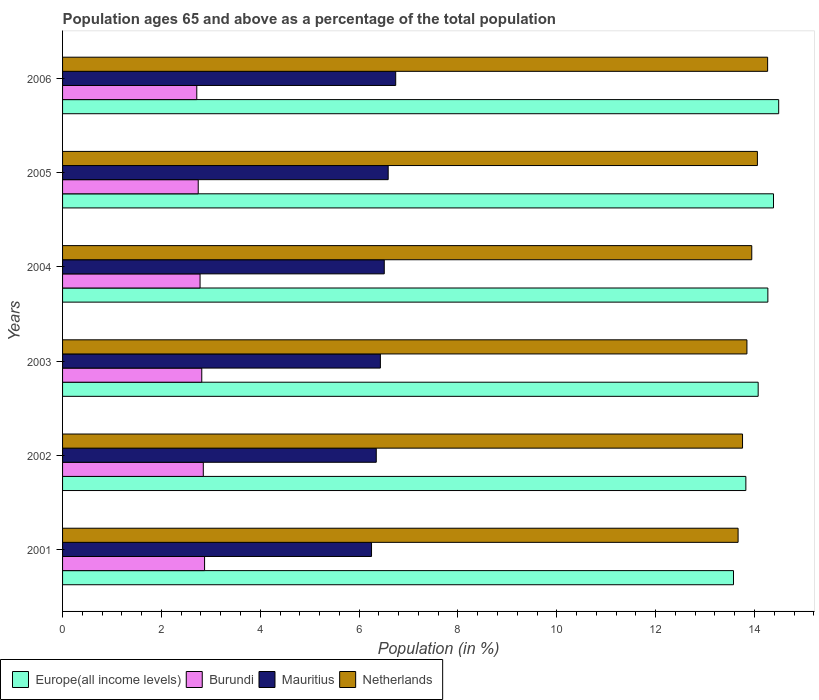Are the number of bars per tick equal to the number of legend labels?
Your answer should be very brief. Yes. Are the number of bars on each tick of the Y-axis equal?
Ensure brevity in your answer.  Yes. How many bars are there on the 4th tick from the top?
Give a very brief answer. 4. In how many cases, is the number of bars for a given year not equal to the number of legend labels?
Ensure brevity in your answer.  0. What is the percentage of the population ages 65 and above in Netherlands in 2001?
Provide a succinct answer. 13.67. Across all years, what is the maximum percentage of the population ages 65 and above in Mauritius?
Your response must be concise. 6.74. Across all years, what is the minimum percentage of the population ages 65 and above in Burundi?
Give a very brief answer. 2.72. In which year was the percentage of the population ages 65 and above in Netherlands maximum?
Give a very brief answer. 2006. What is the total percentage of the population ages 65 and above in Mauritius in the graph?
Make the answer very short. 38.87. What is the difference between the percentage of the population ages 65 and above in Europe(all income levels) in 2003 and that in 2005?
Give a very brief answer. -0.31. What is the difference between the percentage of the population ages 65 and above in Burundi in 2006 and the percentage of the population ages 65 and above in Europe(all income levels) in 2003?
Keep it short and to the point. -11.36. What is the average percentage of the population ages 65 and above in Mauritius per year?
Your response must be concise. 6.48. In the year 2003, what is the difference between the percentage of the population ages 65 and above in Netherlands and percentage of the population ages 65 and above in Mauritius?
Make the answer very short. 7.42. What is the ratio of the percentage of the population ages 65 and above in Burundi in 2002 to that in 2006?
Offer a terse response. 1.05. Is the percentage of the population ages 65 and above in Mauritius in 2002 less than that in 2003?
Offer a very short reply. Yes. Is the difference between the percentage of the population ages 65 and above in Netherlands in 2002 and 2003 greater than the difference between the percentage of the population ages 65 and above in Mauritius in 2002 and 2003?
Your answer should be compact. No. What is the difference between the highest and the second highest percentage of the population ages 65 and above in Netherlands?
Give a very brief answer. 0.21. What is the difference between the highest and the lowest percentage of the population ages 65 and above in Burundi?
Ensure brevity in your answer.  0.16. In how many years, is the percentage of the population ages 65 and above in Netherlands greater than the average percentage of the population ages 65 and above in Netherlands taken over all years?
Your response must be concise. 3. Is it the case that in every year, the sum of the percentage of the population ages 65 and above in Burundi and percentage of the population ages 65 and above in Europe(all income levels) is greater than the sum of percentage of the population ages 65 and above in Netherlands and percentage of the population ages 65 and above in Mauritius?
Offer a very short reply. Yes. What does the 4th bar from the top in 2001 represents?
Make the answer very short. Europe(all income levels). What does the 1st bar from the bottom in 2001 represents?
Your response must be concise. Europe(all income levels). How many years are there in the graph?
Make the answer very short. 6. What is the difference between two consecutive major ticks on the X-axis?
Provide a succinct answer. 2. Does the graph contain any zero values?
Provide a short and direct response. No. Does the graph contain grids?
Your answer should be very brief. No. What is the title of the graph?
Ensure brevity in your answer.  Population ages 65 and above as a percentage of the total population. What is the label or title of the X-axis?
Ensure brevity in your answer.  Population (in %). What is the Population (in %) in Europe(all income levels) in 2001?
Make the answer very short. 13.57. What is the Population (in %) of Burundi in 2001?
Make the answer very short. 2.87. What is the Population (in %) of Mauritius in 2001?
Your response must be concise. 6.25. What is the Population (in %) in Netherlands in 2001?
Your response must be concise. 13.67. What is the Population (in %) in Europe(all income levels) in 2002?
Your response must be concise. 13.83. What is the Population (in %) in Burundi in 2002?
Your answer should be very brief. 2.85. What is the Population (in %) in Mauritius in 2002?
Your answer should be compact. 6.35. What is the Population (in %) of Netherlands in 2002?
Offer a very short reply. 13.76. What is the Population (in %) of Europe(all income levels) in 2003?
Your response must be concise. 14.07. What is the Population (in %) of Burundi in 2003?
Offer a terse response. 2.82. What is the Population (in %) of Mauritius in 2003?
Provide a short and direct response. 6.43. What is the Population (in %) of Netherlands in 2003?
Offer a terse response. 13.85. What is the Population (in %) in Europe(all income levels) in 2004?
Provide a succinct answer. 14.27. What is the Population (in %) of Burundi in 2004?
Your response must be concise. 2.78. What is the Population (in %) in Mauritius in 2004?
Provide a succinct answer. 6.51. What is the Population (in %) in Netherlands in 2004?
Provide a succinct answer. 13.94. What is the Population (in %) in Europe(all income levels) in 2005?
Ensure brevity in your answer.  14.38. What is the Population (in %) in Burundi in 2005?
Offer a terse response. 2.74. What is the Population (in %) in Mauritius in 2005?
Your response must be concise. 6.59. What is the Population (in %) in Netherlands in 2005?
Give a very brief answer. 14.06. What is the Population (in %) of Europe(all income levels) in 2006?
Provide a succinct answer. 14.49. What is the Population (in %) of Burundi in 2006?
Keep it short and to the point. 2.72. What is the Population (in %) of Mauritius in 2006?
Make the answer very short. 6.74. What is the Population (in %) in Netherlands in 2006?
Offer a terse response. 14.27. Across all years, what is the maximum Population (in %) of Europe(all income levels)?
Your response must be concise. 14.49. Across all years, what is the maximum Population (in %) in Burundi?
Your answer should be very brief. 2.87. Across all years, what is the maximum Population (in %) in Mauritius?
Offer a terse response. 6.74. Across all years, what is the maximum Population (in %) in Netherlands?
Ensure brevity in your answer.  14.27. Across all years, what is the minimum Population (in %) of Europe(all income levels)?
Keep it short and to the point. 13.57. Across all years, what is the minimum Population (in %) of Burundi?
Make the answer very short. 2.72. Across all years, what is the minimum Population (in %) of Mauritius?
Give a very brief answer. 6.25. Across all years, what is the minimum Population (in %) of Netherlands?
Offer a very short reply. 13.67. What is the total Population (in %) in Europe(all income levels) in the graph?
Your answer should be very brief. 84.62. What is the total Population (in %) in Burundi in the graph?
Your response must be concise. 16.78. What is the total Population (in %) in Mauritius in the graph?
Make the answer very short. 38.87. What is the total Population (in %) in Netherlands in the graph?
Your response must be concise. 83.54. What is the difference between the Population (in %) in Europe(all income levels) in 2001 and that in 2002?
Offer a terse response. -0.25. What is the difference between the Population (in %) in Burundi in 2001 and that in 2002?
Make the answer very short. 0.03. What is the difference between the Population (in %) in Mauritius in 2001 and that in 2002?
Offer a terse response. -0.1. What is the difference between the Population (in %) of Netherlands in 2001 and that in 2002?
Keep it short and to the point. -0.09. What is the difference between the Population (in %) in Europe(all income levels) in 2001 and that in 2003?
Make the answer very short. -0.5. What is the difference between the Population (in %) in Burundi in 2001 and that in 2003?
Your response must be concise. 0.06. What is the difference between the Population (in %) in Mauritius in 2001 and that in 2003?
Offer a very short reply. -0.18. What is the difference between the Population (in %) of Netherlands in 2001 and that in 2003?
Your answer should be compact. -0.18. What is the difference between the Population (in %) in Europe(all income levels) in 2001 and that in 2004?
Your response must be concise. -0.7. What is the difference between the Population (in %) of Burundi in 2001 and that in 2004?
Offer a terse response. 0.09. What is the difference between the Population (in %) of Mauritius in 2001 and that in 2004?
Give a very brief answer. -0.26. What is the difference between the Population (in %) of Netherlands in 2001 and that in 2004?
Your response must be concise. -0.28. What is the difference between the Population (in %) in Europe(all income levels) in 2001 and that in 2005?
Your response must be concise. -0.81. What is the difference between the Population (in %) of Burundi in 2001 and that in 2005?
Provide a succinct answer. 0.13. What is the difference between the Population (in %) of Mauritius in 2001 and that in 2005?
Your answer should be very brief. -0.34. What is the difference between the Population (in %) of Netherlands in 2001 and that in 2005?
Provide a succinct answer. -0.39. What is the difference between the Population (in %) of Europe(all income levels) in 2001 and that in 2006?
Give a very brief answer. -0.91. What is the difference between the Population (in %) in Burundi in 2001 and that in 2006?
Your answer should be very brief. 0.16. What is the difference between the Population (in %) of Mauritius in 2001 and that in 2006?
Your answer should be compact. -0.49. What is the difference between the Population (in %) in Netherlands in 2001 and that in 2006?
Your answer should be very brief. -0.6. What is the difference between the Population (in %) of Europe(all income levels) in 2002 and that in 2003?
Your answer should be very brief. -0.25. What is the difference between the Population (in %) of Burundi in 2002 and that in 2003?
Give a very brief answer. 0.03. What is the difference between the Population (in %) in Mauritius in 2002 and that in 2003?
Your response must be concise. -0.08. What is the difference between the Population (in %) of Netherlands in 2002 and that in 2003?
Your answer should be very brief. -0.09. What is the difference between the Population (in %) in Europe(all income levels) in 2002 and that in 2004?
Your answer should be compact. -0.45. What is the difference between the Population (in %) in Burundi in 2002 and that in 2004?
Your answer should be very brief. 0.07. What is the difference between the Population (in %) in Mauritius in 2002 and that in 2004?
Make the answer very short. -0.16. What is the difference between the Population (in %) of Netherlands in 2002 and that in 2004?
Keep it short and to the point. -0.19. What is the difference between the Population (in %) of Europe(all income levels) in 2002 and that in 2005?
Provide a short and direct response. -0.56. What is the difference between the Population (in %) of Burundi in 2002 and that in 2005?
Provide a succinct answer. 0.1. What is the difference between the Population (in %) of Mauritius in 2002 and that in 2005?
Your answer should be very brief. -0.24. What is the difference between the Population (in %) of Netherlands in 2002 and that in 2005?
Offer a very short reply. -0.3. What is the difference between the Population (in %) in Europe(all income levels) in 2002 and that in 2006?
Keep it short and to the point. -0.66. What is the difference between the Population (in %) in Burundi in 2002 and that in 2006?
Ensure brevity in your answer.  0.13. What is the difference between the Population (in %) in Mauritius in 2002 and that in 2006?
Give a very brief answer. -0.39. What is the difference between the Population (in %) of Netherlands in 2002 and that in 2006?
Make the answer very short. -0.51. What is the difference between the Population (in %) in Europe(all income levels) in 2003 and that in 2004?
Give a very brief answer. -0.2. What is the difference between the Population (in %) of Burundi in 2003 and that in 2004?
Offer a terse response. 0.03. What is the difference between the Population (in %) in Mauritius in 2003 and that in 2004?
Make the answer very short. -0.08. What is the difference between the Population (in %) in Netherlands in 2003 and that in 2004?
Your answer should be very brief. -0.1. What is the difference between the Population (in %) of Europe(all income levels) in 2003 and that in 2005?
Offer a very short reply. -0.31. What is the difference between the Population (in %) in Burundi in 2003 and that in 2005?
Your answer should be very brief. 0.07. What is the difference between the Population (in %) in Mauritius in 2003 and that in 2005?
Give a very brief answer. -0.16. What is the difference between the Population (in %) of Netherlands in 2003 and that in 2005?
Make the answer very short. -0.21. What is the difference between the Population (in %) of Europe(all income levels) in 2003 and that in 2006?
Provide a succinct answer. -0.41. What is the difference between the Population (in %) in Burundi in 2003 and that in 2006?
Provide a short and direct response. 0.1. What is the difference between the Population (in %) in Mauritius in 2003 and that in 2006?
Give a very brief answer. -0.31. What is the difference between the Population (in %) of Netherlands in 2003 and that in 2006?
Your answer should be very brief. -0.42. What is the difference between the Population (in %) in Europe(all income levels) in 2004 and that in 2005?
Keep it short and to the point. -0.11. What is the difference between the Population (in %) in Burundi in 2004 and that in 2005?
Keep it short and to the point. 0.04. What is the difference between the Population (in %) in Mauritius in 2004 and that in 2005?
Offer a very short reply. -0.08. What is the difference between the Population (in %) in Netherlands in 2004 and that in 2005?
Provide a succinct answer. -0.11. What is the difference between the Population (in %) in Europe(all income levels) in 2004 and that in 2006?
Offer a very short reply. -0.22. What is the difference between the Population (in %) in Burundi in 2004 and that in 2006?
Offer a terse response. 0.07. What is the difference between the Population (in %) of Mauritius in 2004 and that in 2006?
Your response must be concise. -0.23. What is the difference between the Population (in %) of Netherlands in 2004 and that in 2006?
Keep it short and to the point. -0.32. What is the difference between the Population (in %) in Europe(all income levels) in 2005 and that in 2006?
Provide a short and direct response. -0.1. What is the difference between the Population (in %) of Burundi in 2005 and that in 2006?
Offer a terse response. 0.03. What is the difference between the Population (in %) of Mauritius in 2005 and that in 2006?
Give a very brief answer. -0.15. What is the difference between the Population (in %) of Netherlands in 2005 and that in 2006?
Your response must be concise. -0.21. What is the difference between the Population (in %) of Europe(all income levels) in 2001 and the Population (in %) of Burundi in 2002?
Your answer should be very brief. 10.73. What is the difference between the Population (in %) of Europe(all income levels) in 2001 and the Population (in %) of Mauritius in 2002?
Your answer should be very brief. 7.23. What is the difference between the Population (in %) of Europe(all income levels) in 2001 and the Population (in %) of Netherlands in 2002?
Keep it short and to the point. -0.18. What is the difference between the Population (in %) of Burundi in 2001 and the Population (in %) of Mauritius in 2002?
Offer a very short reply. -3.47. What is the difference between the Population (in %) of Burundi in 2001 and the Population (in %) of Netherlands in 2002?
Provide a succinct answer. -10.88. What is the difference between the Population (in %) of Mauritius in 2001 and the Population (in %) of Netherlands in 2002?
Ensure brevity in your answer.  -7.51. What is the difference between the Population (in %) in Europe(all income levels) in 2001 and the Population (in %) in Burundi in 2003?
Your response must be concise. 10.76. What is the difference between the Population (in %) in Europe(all income levels) in 2001 and the Population (in %) in Mauritius in 2003?
Provide a succinct answer. 7.14. What is the difference between the Population (in %) in Europe(all income levels) in 2001 and the Population (in %) in Netherlands in 2003?
Make the answer very short. -0.27. What is the difference between the Population (in %) in Burundi in 2001 and the Population (in %) in Mauritius in 2003?
Provide a succinct answer. -3.56. What is the difference between the Population (in %) of Burundi in 2001 and the Population (in %) of Netherlands in 2003?
Your answer should be very brief. -10.97. What is the difference between the Population (in %) in Mauritius in 2001 and the Population (in %) in Netherlands in 2003?
Provide a short and direct response. -7.6. What is the difference between the Population (in %) in Europe(all income levels) in 2001 and the Population (in %) in Burundi in 2004?
Give a very brief answer. 10.79. What is the difference between the Population (in %) of Europe(all income levels) in 2001 and the Population (in %) of Mauritius in 2004?
Offer a very short reply. 7.07. What is the difference between the Population (in %) of Europe(all income levels) in 2001 and the Population (in %) of Netherlands in 2004?
Your response must be concise. -0.37. What is the difference between the Population (in %) in Burundi in 2001 and the Population (in %) in Mauritius in 2004?
Provide a short and direct response. -3.64. What is the difference between the Population (in %) in Burundi in 2001 and the Population (in %) in Netherlands in 2004?
Provide a succinct answer. -11.07. What is the difference between the Population (in %) of Mauritius in 2001 and the Population (in %) of Netherlands in 2004?
Keep it short and to the point. -7.69. What is the difference between the Population (in %) of Europe(all income levels) in 2001 and the Population (in %) of Burundi in 2005?
Ensure brevity in your answer.  10.83. What is the difference between the Population (in %) in Europe(all income levels) in 2001 and the Population (in %) in Mauritius in 2005?
Your response must be concise. 6.99. What is the difference between the Population (in %) of Europe(all income levels) in 2001 and the Population (in %) of Netherlands in 2005?
Offer a very short reply. -0.48. What is the difference between the Population (in %) in Burundi in 2001 and the Population (in %) in Mauritius in 2005?
Keep it short and to the point. -3.71. What is the difference between the Population (in %) of Burundi in 2001 and the Population (in %) of Netherlands in 2005?
Your response must be concise. -11.19. What is the difference between the Population (in %) of Mauritius in 2001 and the Population (in %) of Netherlands in 2005?
Your answer should be very brief. -7.81. What is the difference between the Population (in %) of Europe(all income levels) in 2001 and the Population (in %) of Burundi in 2006?
Make the answer very short. 10.86. What is the difference between the Population (in %) in Europe(all income levels) in 2001 and the Population (in %) in Mauritius in 2006?
Make the answer very short. 6.83. What is the difference between the Population (in %) of Europe(all income levels) in 2001 and the Population (in %) of Netherlands in 2006?
Your answer should be compact. -0.69. What is the difference between the Population (in %) of Burundi in 2001 and the Population (in %) of Mauritius in 2006?
Your response must be concise. -3.87. What is the difference between the Population (in %) of Burundi in 2001 and the Population (in %) of Netherlands in 2006?
Keep it short and to the point. -11.39. What is the difference between the Population (in %) of Mauritius in 2001 and the Population (in %) of Netherlands in 2006?
Your response must be concise. -8.01. What is the difference between the Population (in %) in Europe(all income levels) in 2002 and the Population (in %) in Burundi in 2003?
Your answer should be compact. 11.01. What is the difference between the Population (in %) of Europe(all income levels) in 2002 and the Population (in %) of Mauritius in 2003?
Make the answer very short. 7.39. What is the difference between the Population (in %) in Europe(all income levels) in 2002 and the Population (in %) in Netherlands in 2003?
Give a very brief answer. -0.02. What is the difference between the Population (in %) of Burundi in 2002 and the Population (in %) of Mauritius in 2003?
Keep it short and to the point. -3.58. What is the difference between the Population (in %) of Burundi in 2002 and the Population (in %) of Netherlands in 2003?
Offer a very short reply. -11. What is the difference between the Population (in %) of Mauritius in 2002 and the Population (in %) of Netherlands in 2003?
Offer a very short reply. -7.5. What is the difference between the Population (in %) of Europe(all income levels) in 2002 and the Population (in %) of Burundi in 2004?
Your response must be concise. 11.04. What is the difference between the Population (in %) in Europe(all income levels) in 2002 and the Population (in %) in Mauritius in 2004?
Provide a succinct answer. 7.32. What is the difference between the Population (in %) in Europe(all income levels) in 2002 and the Population (in %) in Netherlands in 2004?
Ensure brevity in your answer.  -0.12. What is the difference between the Population (in %) in Burundi in 2002 and the Population (in %) in Mauritius in 2004?
Provide a short and direct response. -3.66. What is the difference between the Population (in %) of Burundi in 2002 and the Population (in %) of Netherlands in 2004?
Offer a very short reply. -11.1. What is the difference between the Population (in %) of Mauritius in 2002 and the Population (in %) of Netherlands in 2004?
Make the answer very short. -7.6. What is the difference between the Population (in %) in Europe(all income levels) in 2002 and the Population (in %) in Burundi in 2005?
Keep it short and to the point. 11.08. What is the difference between the Population (in %) of Europe(all income levels) in 2002 and the Population (in %) of Mauritius in 2005?
Offer a terse response. 7.24. What is the difference between the Population (in %) in Europe(all income levels) in 2002 and the Population (in %) in Netherlands in 2005?
Provide a succinct answer. -0.23. What is the difference between the Population (in %) of Burundi in 2002 and the Population (in %) of Mauritius in 2005?
Provide a succinct answer. -3.74. What is the difference between the Population (in %) of Burundi in 2002 and the Population (in %) of Netherlands in 2005?
Your answer should be compact. -11.21. What is the difference between the Population (in %) in Mauritius in 2002 and the Population (in %) in Netherlands in 2005?
Provide a succinct answer. -7.71. What is the difference between the Population (in %) of Europe(all income levels) in 2002 and the Population (in %) of Burundi in 2006?
Ensure brevity in your answer.  11.11. What is the difference between the Population (in %) of Europe(all income levels) in 2002 and the Population (in %) of Mauritius in 2006?
Provide a short and direct response. 7.08. What is the difference between the Population (in %) of Europe(all income levels) in 2002 and the Population (in %) of Netherlands in 2006?
Your response must be concise. -0.44. What is the difference between the Population (in %) of Burundi in 2002 and the Population (in %) of Mauritius in 2006?
Keep it short and to the point. -3.89. What is the difference between the Population (in %) of Burundi in 2002 and the Population (in %) of Netherlands in 2006?
Your answer should be compact. -11.42. What is the difference between the Population (in %) in Mauritius in 2002 and the Population (in %) in Netherlands in 2006?
Ensure brevity in your answer.  -7.92. What is the difference between the Population (in %) of Europe(all income levels) in 2003 and the Population (in %) of Burundi in 2004?
Keep it short and to the point. 11.29. What is the difference between the Population (in %) in Europe(all income levels) in 2003 and the Population (in %) in Mauritius in 2004?
Provide a short and direct response. 7.57. What is the difference between the Population (in %) in Europe(all income levels) in 2003 and the Population (in %) in Netherlands in 2004?
Make the answer very short. 0.13. What is the difference between the Population (in %) in Burundi in 2003 and the Population (in %) in Mauritius in 2004?
Provide a short and direct response. -3.69. What is the difference between the Population (in %) of Burundi in 2003 and the Population (in %) of Netherlands in 2004?
Provide a succinct answer. -11.13. What is the difference between the Population (in %) in Mauritius in 2003 and the Population (in %) in Netherlands in 2004?
Offer a terse response. -7.51. What is the difference between the Population (in %) of Europe(all income levels) in 2003 and the Population (in %) of Burundi in 2005?
Offer a very short reply. 11.33. What is the difference between the Population (in %) of Europe(all income levels) in 2003 and the Population (in %) of Mauritius in 2005?
Your answer should be very brief. 7.49. What is the difference between the Population (in %) of Europe(all income levels) in 2003 and the Population (in %) of Netherlands in 2005?
Keep it short and to the point. 0.02. What is the difference between the Population (in %) in Burundi in 2003 and the Population (in %) in Mauritius in 2005?
Provide a succinct answer. -3.77. What is the difference between the Population (in %) of Burundi in 2003 and the Population (in %) of Netherlands in 2005?
Your response must be concise. -11.24. What is the difference between the Population (in %) of Mauritius in 2003 and the Population (in %) of Netherlands in 2005?
Make the answer very short. -7.63. What is the difference between the Population (in %) in Europe(all income levels) in 2003 and the Population (in %) in Burundi in 2006?
Give a very brief answer. 11.36. What is the difference between the Population (in %) of Europe(all income levels) in 2003 and the Population (in %) of Mauritius in 2006?
Ensure brevity in your answer.  7.33. What is the difference between the Population (in %) in Europe(all income levels) in 2003 and the Population (in %) in Netherlands in 2006?
Offer a very short reply. -0.19. What is the difference between the Population (in %) in Burundi in 2003 and the Population (in %) in Mauritius in 2006?
Offer a very short reply. -3.92. What is the difference between the Population (in %) of Burundi in 2003 and the Population (in %) of Netherlands in 2006?
Ensure brevity in your answer.  -11.45. What is the difference between the Population (in %) in Mauritius in 2003 and the Population (in %) in Netherlands in 2006?
Provide a short and direct response. -7.83. What is the difference between the Population (in %) of Europe(all income levels) in 2004 and the Population (in %) of Burundi in 2005?
Make the answer very short. 11.53. What is the difference between the Population (in %) of Europe(all income levels) in 2004 and the Population (in %) of Mauritius in 2005?
Give a very brief answer. 7.68. What is the difference between the Population (in %) in Europe(all income levels) in 2004 and the Population (in %) in Netherlands in 2005?
Ensure brevity in your answer.  0.21. What is the difference between the Population (in %) in Burundi in 2004 and the Population (in %) in Mauritius in 2005?
Your response must be concise. -3.81. What is the difference between the Population (in %) in Burundi in 2004 and the Population (in %) in Netherlands in 2005?
Make the answer very short. -11.28. What is the difference between the Population (in %) in Mauritius in 2004 and the Population (in %) in Netherlands in 2005?
Provide a succinct answer. -7.55. What is the difference between the Population (in %) in Europe(all income levels) in 2004 and the Population (in %) in Burundi in 2006?
Provide a succinct answer. 11.55. What is the difference between the Population (in %) of Europe(all income levels) in 2004 and the Population (in %) of Mauritius in 2006?
Offer a terse response. 7.53. What is the difference between the Population (in %) in Europe(all income levels) in 2004 and the Population (in %) in Netherlands in 2006?
Offer a very short reply. 0. What is the difference between the Population (in %) of Burundi in 2004 and the Population (in %) of Mauritius in 2006?
Offer a very short reply. -3.96. What is the difference between the Population (in %) of Burundi in 2004 and the Population (in %) of Netherlands in 2006?
Give a very brief answer. -11.48. What is the difference between the Population (in %) in Mauritius in 2004 and the Population (in %) in Netherlands in 2006?
Keep it short and to the point. -7.76. What is the difference between the Population (in %) of Europe(all income levels) in 2005 and the Population (in %) of Burundi in 2006?
Offer a very short reply. 11.67. What is the difference between the Population (in %) in Europe(all income levels) in 2005 and the Population (in %) in Mauritius in 2006?
Offer a very short reply. 7.64. What is the difference between the Population (in %) of Europe(all income levels) in 2005 and the Population (in %) of Netherlands in 2006?
Provide a short and direct response. 0.12. What is the difference between the Population (in %) of Burundi in 2005 and the Population (in %) of Mauritius in 2006?
Give a very brief answer. -4. What is the difference between the Population (in %) in Burundi in 2005 and the Population (in %) in Netherlands in 2006?
Your answer should be very brief. -11.52. What is the difference between the Population (in %) in Mauritius in 2005 and the Population (in %) in Netherlands in 2006?
Your response must be concise. -7.68. What is the average Population (in %) in Europe(all income levels) per year?
Your answer should be very brief. 14.1. What is the average Population (in %) in Burundi per year?
Your answer should be very brief. 2.8. What is the average Population (in %) of Mauritius per year?
Offer a very short reply. 6.48. What is the average Population (in %) of Netherlands per year?
Offer a terse response. 13.92. In the year 2001, what is the difference between the Population (in %) in Europe(all income levels) and Population (in %) in Burundi?
Offer a very short reply. 10.7. In the year 2001, what is the difference between the Population (in %) of Europe(all income levels) and Population (in %) of Mauritius?
Your answer should be very brief. 7.32. In the year 2001, what is the difference between the Population (in %) in Europe(all income levels) and Population (in %) in Netherlands?
Provide a succinct answer. -0.09. In the year 2001, what is the difference between the Population (in %) in Burundi and Population (in %) in Mauritius?
Keep it short and to the point. -3.38. In the year 2001, what is the difference between the Population (in %) in Burundi and Population (in %) in Netherlands?
Ensure brevity in your answer.  -10.79. In the year 2001, what is the difference between the Population (in %) in Mauritius and Population (in %) in Netherlands?
Keep it short and to the point. -7.42. In the year 2002, what is the difference between the Population (in %) in Europe(all income levels) and Population (in %) in Burundi?
Offer a very short reply. 10.98. In the year 2002, what is the difference between the Population (in %) of Europe(all income levels) and Population (in %) of Mauritius?
Provide a short and direct response. 7.48. In the year 2002, what is the difference between the Population (in %) of Europe(all income levels) and Population (in %) of Netherlands?
Keep it short and to the point. 0.07. In the year 2002, what is the difference between the Population (in %) in Burundi and Population (in %) in Mauritius?
Provide a succinct answer. -3.5. In the year 2002, what is the difference between the Population (in %) of Burundi and Population (in %) of Netherlands?
Your response must be concise. -10.91. In the year 2002, what is the difference between the Population (in %) in Mauritius and Population (in %) in Netherlands?
Ensure brevity in your answer.  -7.41. In the year 2003, what is the difference between the Population (in %) of Europe(all income levels) and Population (in %) of Burundi?
Give a very brief answer. 11.26. In the year 2003, what is the difference between the Population (in %) in Europe(all income levels) and Population (in %) in Mauritius?
Offer a very short reply. 7.64. In the year 2003, what is the difference between the Population (in %) in Europe(all income levels) and Population (in %) in Netherlands?
Your answer should be very brief. 0.23. In the year 2003, what is the difference between the Population (in %) in Burundi and Population (in %) in Mauritius?
Provide a short and direct response. -3.61. In the year 2003, what is the difference between the Population (in %) in Burundi and Population (in %) in Netherlands?
Provide a short and direct response. -11.03. In the year 2003, what is the difference between the Population (in %) in Mauritius and Population (in %) in Netherlands?
Provide a succinct answer. -7.42. In the year 2004, what is the difference between the Population (in %) in Europe(all income levels) and Population (in %) in Burundi?
Give a very brief answer. 11.49. In the year 2004, what is the difference between the Population (in %) of Europe(all income levels) and Population (in %) of Mauritius?
Ensure brevity in your answer.  7.76. In the year 2004, what is the difference between the Population (in %) of Europe(all income levels) and Population (in %) of Netherlands?
Provide a short and direct response. 0.33. In the year 2004, what is the difference between the Population (in %) of Burundi and Population (in %) of Mauritius?
Make the answer very short. -3.73. In the year 2004, what is the difference between the Population (in %) in Burundi and Population (in %) in Netherlands?
Provide a succinct answer. -11.16. In the year 2004, what is the difference between the Population (in %) of Mauritius and Population (in %) of Netherlands?
Make the answer very short. -7.44. In the year 2005, what is the difference between the Population (in %) of Europe(all income levels) and Population (in %) of Burundi?
Your answer should be compact. 11.64. In the year 2005, what is the difference between the Population (in %) of Europe(all income levels) and Population (in %) of Mauritius?
Offer a terse response. 7.8. In the year 2005, what is the difference between the Population (in %) of Europe(all income levels) and Population (in %) of Netherlands?
Your answer should be compact. 0.33. In the year 2005, what is the difference between the Population (in %) in Burundi and Population (in %) in Mauritius?
Your response must be concise. -3.84. In the year 2005, what is the difference between the Population (in %) in Burundi and Population (in %) in Netherlands?
Ensure brevity in your answer.  -11.31. In the year 2005, what is the difference between the Population (in %) of Mauritius and Population (in %) of Netherlands?
Give a very brief answer. -7.47. In the year 2006, what is the difference between the Population (in %) in Europe(all income levels) and Population (in %) in Burundi?
Provide a succinct answer. 11.77. In the year 2006, what is the difference between the Population (in %) in Europe(all income levels) and Population (in %) in Mauritius?
Your response must be concise. 7.75. In the year 2006, what is the difference between the Population (in %) of Europe(all income levels) and Population (in %) of Netherlands?
Make the answer very short. 0.22. In the year 2006, what is the difference between the Population (in %) in Burundi and Population (in %) in Mauritius?
Make the answer very short. -4.02. In the year 2006, what is the difference between the Population (in %) of Burundi and Population (in %) of Netherlands?
Your answer should be very brief. -11.55. In the year 2006, what is the difference between the Population (in %) of Mauritius and Population (in %) of Netherlands?
Give a very brief answer. -7.53. What is the ratio of the Population (in %) in Europe(all income levels) in 2001 to that in 2002?
Provide a short and direct response. 0.98. What is the ratio of the Population (in %) in Burundi in 2001 to that in 2002?
Ensure brevity in your answer.  1.01. What is the ratio of the Population (in %) in Mauritius in 2001 to that in 2002?
Offer a terse response. 0.98. What is the ratio of the Population (in %) of Netherlands in 2001 to that in 2002?
Provide a short and direct response. 0.99. What is the ratio of the Population (in %) in Europe(all income levels) in 2001 to that in 2003?
Provide a short and direct response. 0.96. What is the ratio of the Population (in %) of Burundi in 2001 to that in 2003?
Offer a very short reply. 1.02. What is the ratio of the Population (in %) in Mauritius in 2001 to that in 2003?
Keep it short and to the point. 0.97. What is the ratio of the Population (in %) of Netherlands in 2001 to that in 2003?
Your response must be concise. 0.99. What is the ratio of the Population (in %) of Europe(all income levels) in 2001 to that in 2004?
Your answer should be very brief. 0.95. What is the ratio of the Population (in %) of Burundi in 2001 to that in 2004?
Give a very brief answer. 1.03. What is the ratio of the Population (in %) in Mauritius in 2001 to that in 2004?
Provide a succinct answer. 0.96. What is the ratio of the Population (in %) in Netherlands in 2001 to that in 2004?
Your answer should be very brief. 0.98. What is the ratio of the Population (in %) in Europe(all income levels) in 2001 to that in 2005?
Keep it short and to the point. 0.94. What is the ratio of the Population (in %) of Burundi in 2001 to that in 2005?
Provide a short and direct response. 1.05. What is the ratio of the Population (in %) in Mauritius in 2001 to that in 2005?
Your answer should be very brief. 0.95. What is the ratio of the Population (in %) in Netherlands in 2001 to that in 2005?
Provide a succinct answer. 0.97. What is the ratio of the Population (in %) of Europe(all income levels) in 2001 to that in 2006?
Ensure brevity in your answer.  0.94. What is the ratio of the Population (in %) of Burundi in 2001 to that in 2006?
Offer a very short reply. 1.06. What is the ratio of the Population (in %) in Mauritius in 2001 to that in 2006?
Your response must be concise. 0.93. What is the ratio of the Population (in %) of Netherlands in 2001 to that in 2006?
Keep it short and to the point. 0.96. What is the ratio of the Population (in %) in Europe(all income levels) in 2002 to that in 2003?
Give a very brief answer. 0.98. What is the ratio of the Population (in %) of Burundi in 2002 to that in 2003?
Offer a very short reply. 1.01. What is the ratio of the Population (in %) of Mauritius in 2002 to that in 2003?
Offer a very short reply. 0.99. What is the ratio of the Population (in %) in Netherlands in 2002 to that in 2003?
Your answer should be compact. 0.99. What is the ratio of the Population (in %) of Europe(all income levels) in 2002 to that in 2004?
Your answer should be compact. 0.97. What is the ratio of the Population (in %) in Burundi in 2002 to that in 2004?
Ensure brevity in your answer.  1.02. What is the ratio of the Population (in %) in Mauritius in 2002 to that in 2004?
Make the answer very short. 0.98. What is the ratio of the Population (in %) of Netherlands in 2002 to that in 2004?
Ensure brevity in your answer.  0.99. What is the ratio of the Population (in %) in Europe(all income levels) in 2002 to that in 2005?
Make the answer very short. 0.96. What is the ratio of the Population (in %) of Burundi in 2002 to that in 2005?
Your response must be concise. 1.04. What is the ratio of the Population (in %) in Mauritius in 2002 to that in 2005?
Make the answer very short. 0.96. What is the ratio of the Population (in %) in Netherlands in 2002 to that in 2005?
Make the answer very short. 0.98. What is the ratio of the Population (in %) of Europe(all income levels) in 2002 to that in 2006?
Make the answer very short. 0.95. What is the ratio of the Population (in %) of Burundi in 2002 to that in 2006?
Your answer should be very brief. 1.05. What is the ratio of the Population (in %) in Mauritius in 2002 to that in 2006?
Your response must be concise. 0.94. What is the ratio of the Population (in %) in Netherlands in 2002 to that in 2006?
Your answer should be compact. 0.96. What is the ratio of the Population (in %) of Europe(all income levels) in 2003 to that in 2004?
Keep it short and to the point. 0.99. What is the ratio of the Population (in %) in Burundi in 2003 to that in 2004?
Offer a very short reply. 1.01. What is the ratio of the Population (in %) in Europe(all income levels) in 2003 to that in 2005?
Your answer should be very brief. 0.98. What is the ratio of the Population (in %) of Burundi in 2003 to that in 2005?
Your response must be concise. 1.03. What is the ratio of the Population (in %) of Mauritius in 2003 to that in 2005?
Your answer should be very brief. 0.98. What is the ratio of the Population (in %) in Netherlands in 2003 to that in 2005?
Give a very brief answer. 0.98. What is the ratio of the Population (in %) of Europe(all income levels) in 2003 to that in 2006?
Ensure brevity in your answer.  0.97. What is the ratio of the Population (in %) in Burundi in 2003 to that in 2006?
Ensure brevity in your answer.  1.04. What is the ratio of the Population (in %) in Mauritius in 2003 to that in 2006?
Give a very brief answer. 0.95. What is the ratio of the Population (in %) of Netherlands in 2003 to that in 2006?
Your response must be concise. 0.97. What is the ratio of the Population (in %) in Europe(all income levels) in 2004 to that in 2005?
Provide a succinct answer. 0.99. What is the ratio of the Population (in %) of Burundi in 2004 to that in 2005?
Your answer should be very brief. 1.01. What is the ratio of the Population (in %) of Mauritius in 2004 to that in 2005?
Offer a terse response. 0.99. What is the ratio of the Population (in %) in Europe(all income levels) in 2004 to that in 2006?
Give a very brief answer. 0.98. What is the ratio of the Population (in %) in Burundi in 2004 to that in 2006?
Give a very brief answer. 1.02. What is the ratio of the Population (in %) in Mauritius in 2004 to that in 2006?
Ensure brevity in your answer.  0.97. What is the ratio of the Population (in %) of Netherlands in 2004 to that in 2006?
Provide a short and direct response. 0.98. What is the ratio of the Population (in %) in Burundi in 2005 to that in 2006?
Make the answer very short. 1.01. What is the ratio of the Population (in %) in Mauritius in 2005 to that in 2006?
Keep it short and to the point. 0.98. What is the ratio of the Population (in %) of Netherlands in 2005 to that in 2006?
Make the answer very short. 0.99. What is the difference between the highest and the second highest Population (in %) of Europe(all income levels)?
Ensure brevity in your answer.  0.1. What is the difference between the highest and the second highest Population (in %) of Burundi?
Make the answer very short. 0.03. What is the difference between the highest and the second highest Population (in %) in Mauritius?
Your answer should be compact. 0.15. What is the difference between the highest and the second highest Population (in %) of Netherlands?
Offer a very short reply. 0.21. What is the difference between the highest and the lowest Population (in %) in Europe(all income levels)?
Offer a very short reply. 0.91. What is the difference between the highest and the lowest Population (in %) in Burundi?
Provide a succinct answer. 0.16. What is the difference between the highest and the lowest Population (in %) in Mauritius?
Give a very brief answer. 0.49. What is the difference between the highest and the lowest Population (in %) of Netherlands?
Your answer should be very brief. 0.6. 